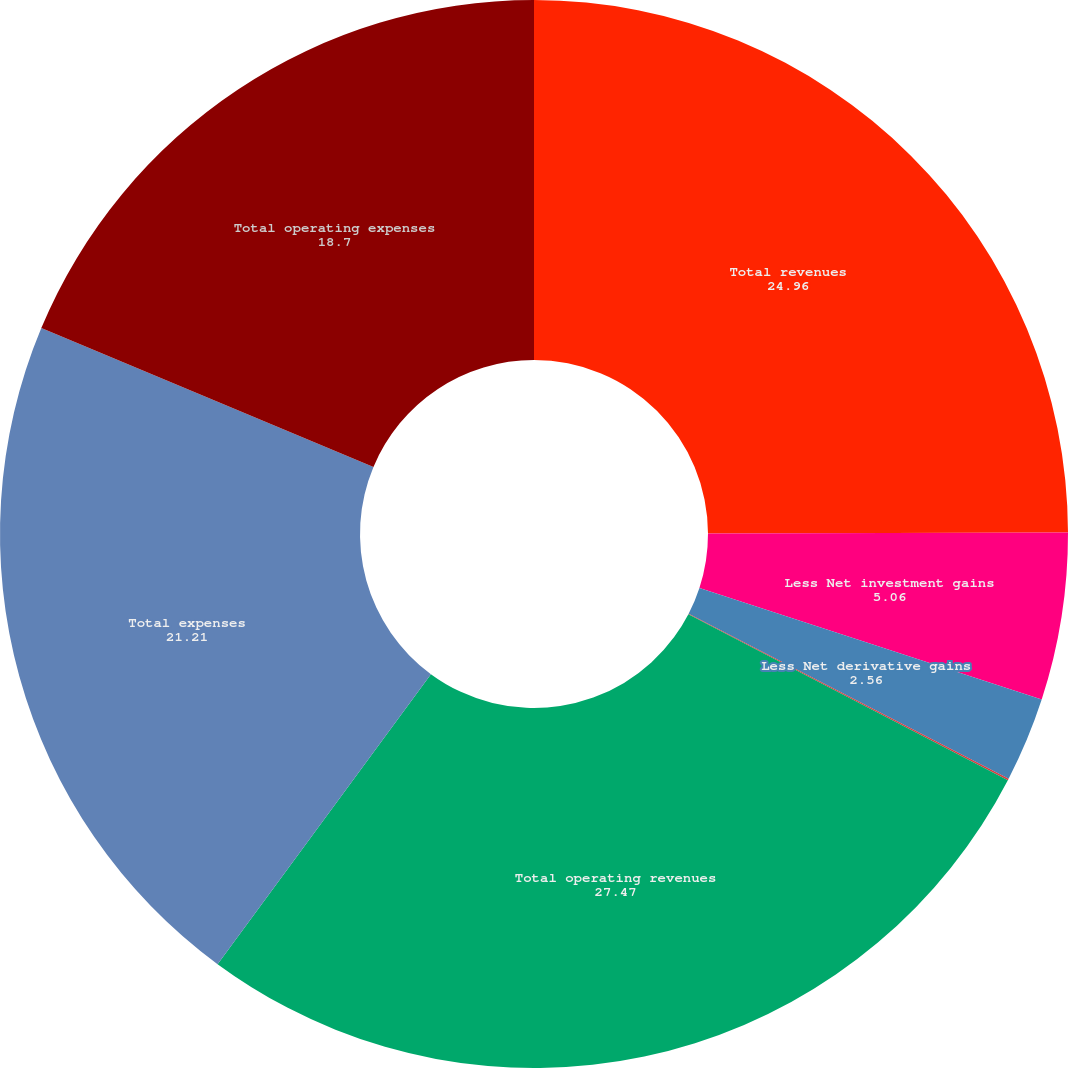<chart> <loc_0><loc_0><loc_500><loc_500><pie_chart><fcel>Total revenues<fcel>Less Net investment gains<fcel>Less Net derivative gains<fcel>Less Other adjustments to<fcel>Total operating revenues<fcel>Total expenses<fcel>Total operating expenses<nl><fcel>24.96%<fcel>5.06%<fcel>2.56%<fcel>0.05%<fcel>27.47%<fcel>21.21%<fcel>18.7%<nl></chart> 